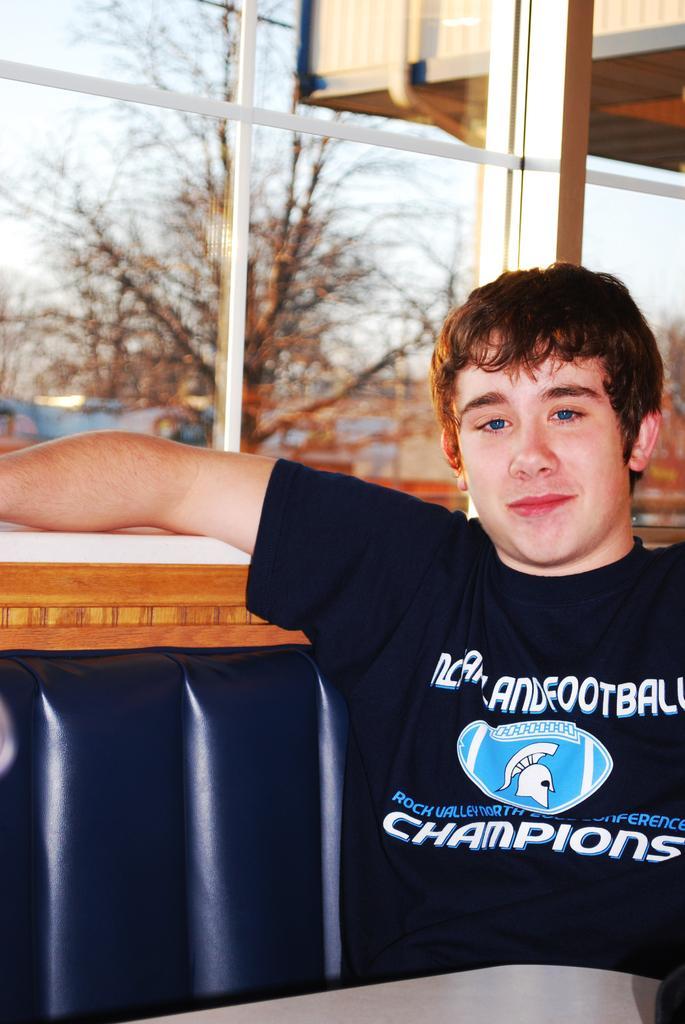Describe this image in one or two sentences. In this image, on the right side, we can see a man sitting on the couch. In the background, we can see a glass window, outside of the glass window, we can see some trees, buildings. At the top, we can see a sky. 